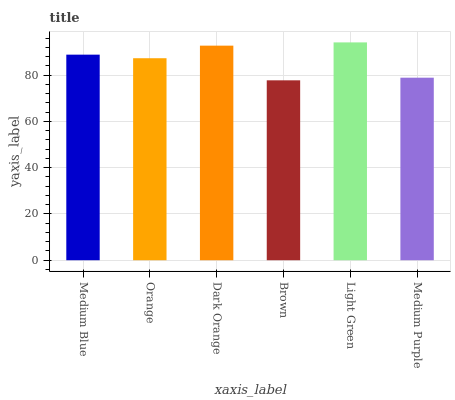Is Brown the minimum?
Answer yes or no. Yes. Is Light Green the maximum?
Answer yes or no. Yes. Is Orange the minimum?
Answer yes or no. No. Is Orange the maximum?
Answer yes or no. No. Is Medium Blue greater than Orange?
Answer yes or no. Yes. Is Orange less than Medium Blue?
Answer yes or no. Yes. Is Orange greater than Medium Blue?
Answer yes or no. No. Is Medium Blue less than Orange?
Answer yes or no. No. Is Medium Blue the high median?
Answer yes or no. Yes. Is Orange the low median?
Answer yes or no. Yes. Is Orange the high median?
Answer yes or no. No. Is Medium Purple the low median?
Answer yes or no. No. 